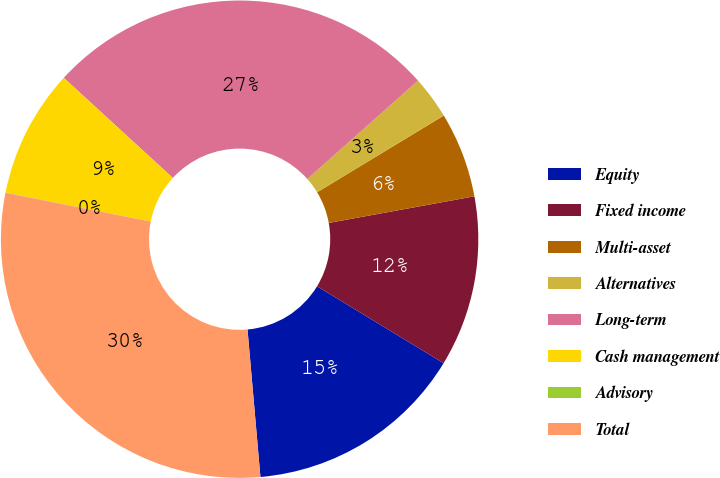<chart> <loc_0><loc_0><loc_500><loc_500><pie_chart><fcel>Equity<fcel>Fixed income<fcel>Multi-asset<fcel>Alternatives<fcel>Long-term<fcel>Cash management<fcel>Advisory<fcel>Total<nl><fcel>14.92%<fcel>11.57%<fcel>5.79%<fcel>2.9%<fcel>26.62%<fcel>8.68%<fcel>0.02%<fcel>29.51%<nl></chart> 